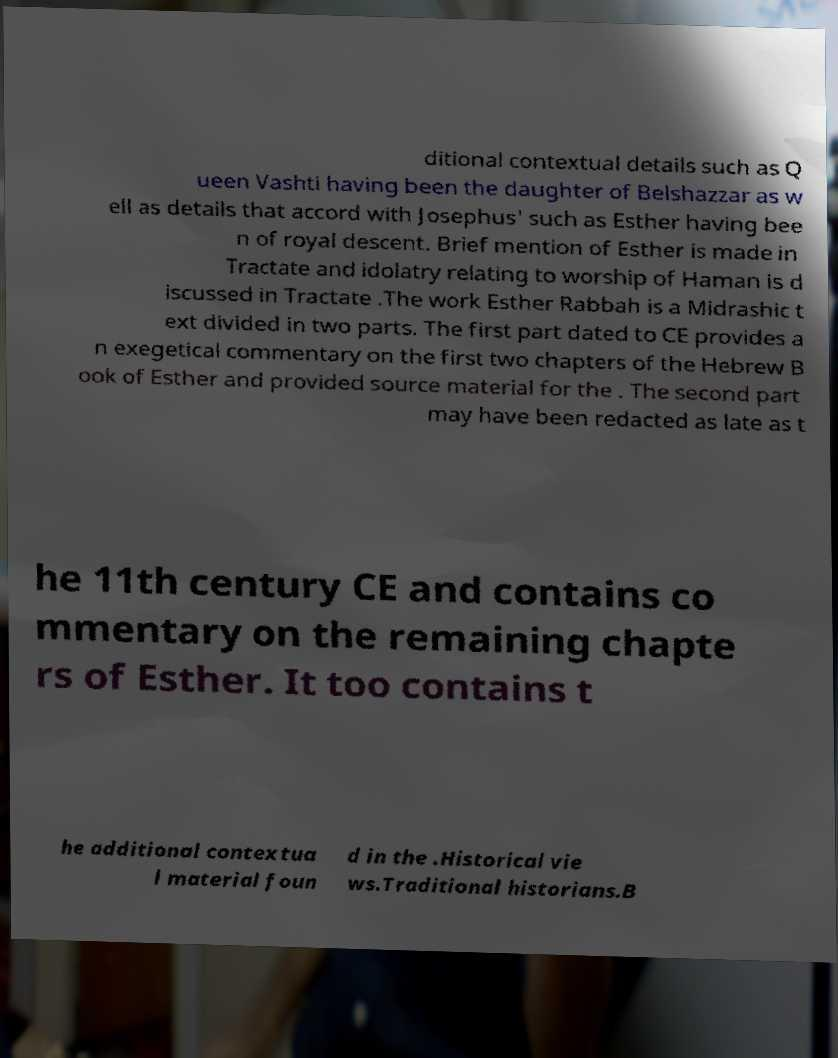Could you assist in decoding the text presented in this image and type it out clearly? ditional contextual details such as Q ueen Vashti having been the daughter of Belshazzar as w ell as details that accord with Josephus' such as Esther having bee n of royal descent. Brief mention of Esther is made in Tractate and idolatry relating to worship of Haman is d iscussed in Tractate .The work Esther Rabbah is a Midrashic t ext divided in two parts. The first part dated to CE provides a n exegetical commentary on the first two chapters of the Hebrew B ook of Esther and provided source material for the . The second part may have been redacted as late as t he 11th century CE and contains co mmentary on the remaining chapte rs of Esther. It too contains t he additional contextua l material foun d in the .Historical vie ws.Traditional historians.B 